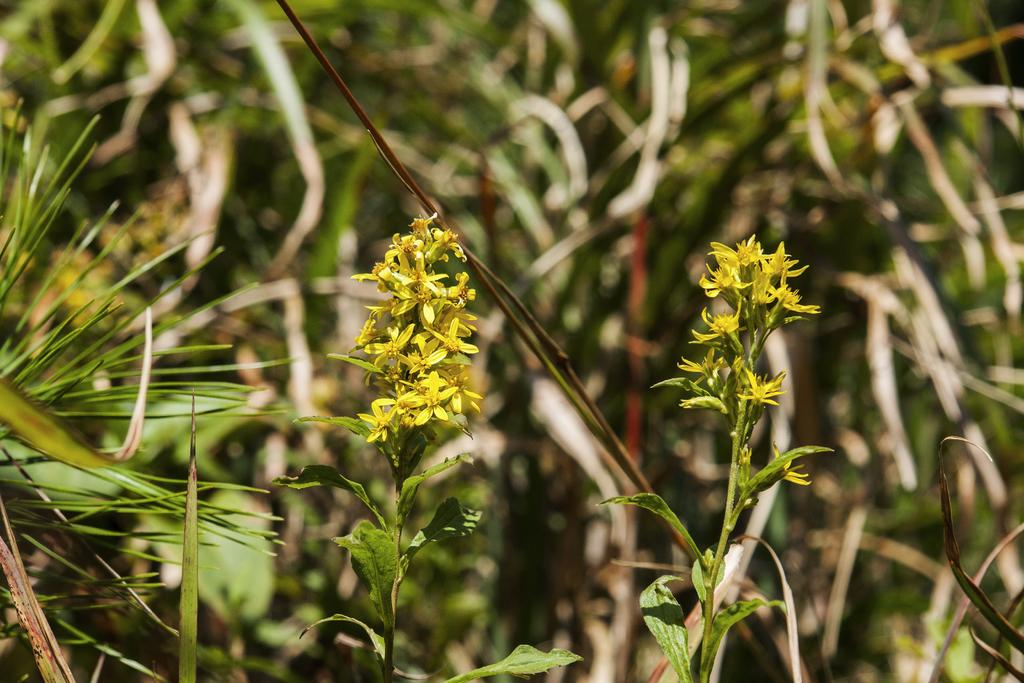What type of flowers can be seen in the image? There are yellow flowers in the image. Can you describe the structure of the flowers? The flowers have stems. What type of relation is depicted between the flowers and breakfast in the image? There is no reference to breakfast in the image, so it is not possible to determine any relation between the flowers and breakfast. 